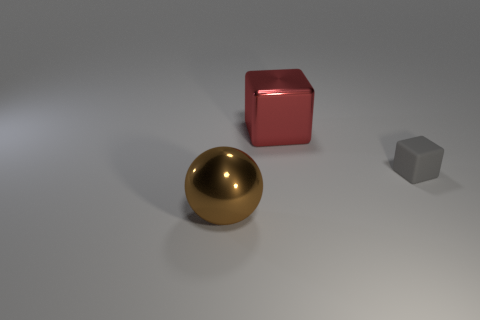Add 2 small blocks. How many objects exist? 5 Subtract all cubes. How many objects are left? 1 Add 2 yellow matte cylinders. How many yellow matte cylinders exist? 2 Subtract 0 cyan cylinders. How many objects are left? 3 Subtract all big objects. Subtract all red objects. How many objects are left? 0 Add 3 large red metal things. How many large red metal things are left? 4 